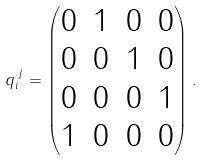<formula> <loc_0><loc_0><loc_500><loc_500>q _ { i } ^ { . j } = \begin{pmatrix} 0 & 1 & 0 & 0 \\ 0 & 0 & 1 & 0 \\ 0 & 0 & 0 & 1 \\ 1 & 0 & 0 & 0 \\ \end{pmatrix} .</formula> 